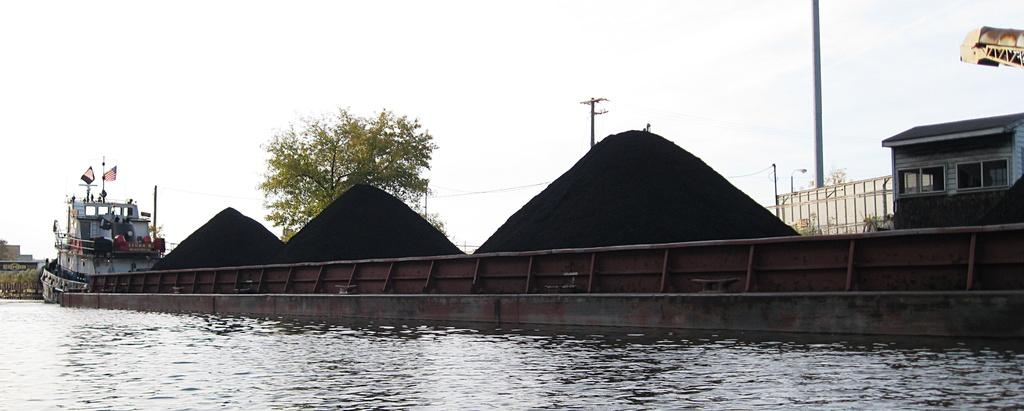What is visible in the foreground of the image? There is water in the foreground of the image. What can be seen in the background of the image? There are heaps of dirt, a ship, a tree, poles, a house, and the sky visible in the background of the image. How many structures are present in the background of the image? There are at least two structures present in the background of the image: a house and a ship. What type of natural element is visible in the background of the image? There is a tree visible in the background of the image. Can you tell me how many bees are buzzing around the tree in the image? There are no bees present in the image; it only features a tree, water, and various structures in the background. What is the level of interest in the land depicted in the image? The level of interest in the land cannot be determined from the image alone, as it only provides a visual representation of the scene. 